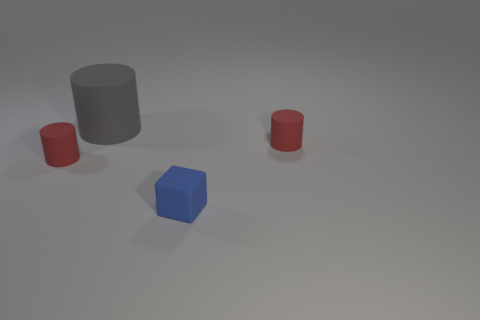How many other objects are the same shape as the gray object?
Offer a terse response. 2. Are there more blue rubber blocks that are to the right of the large gray cylinder than gray things in front of the blue rubber object?
Offer a very short reply. Yes. What number of other things are the same size as the gray matte cylinder?
Your answer should be compact. 0. There is a small thing to the left of the large gray rubber cylinder; does it have the same color as the large cylinder?
Your answer should be compact. No. Are there more gray cylinders that are right of the large matte cylinder than large cyan matte cylinders?
Make the answer very short. No. Is there anything else of the same color as the large matte thing?
Make the answer very short. No. The small red thing in front of the small red cylinder that is to the right of the big gray thing is what shape?
Provide a succinct answer. Cylinder. Is the number of tiny green metallic cylinders greater than the number of blue rubber blocks?
Offer a terse response. No. How many tiny red matte objects are both to the right of the tiny block and on the left side of the large gray matte cylinder?
Your answer should be very brief. 0. There is a tiny rubber cylinder that is to the right of the large matte thing; what number of red matte things are in front of it?
Your response must be concise. 1. 